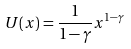<formula> <loc_0><loc_0><loc_500><loc_500>U ( x ) = \frac { 1 } { 1 - \gamma } x ^ { 1 - \gamma }</formula> 